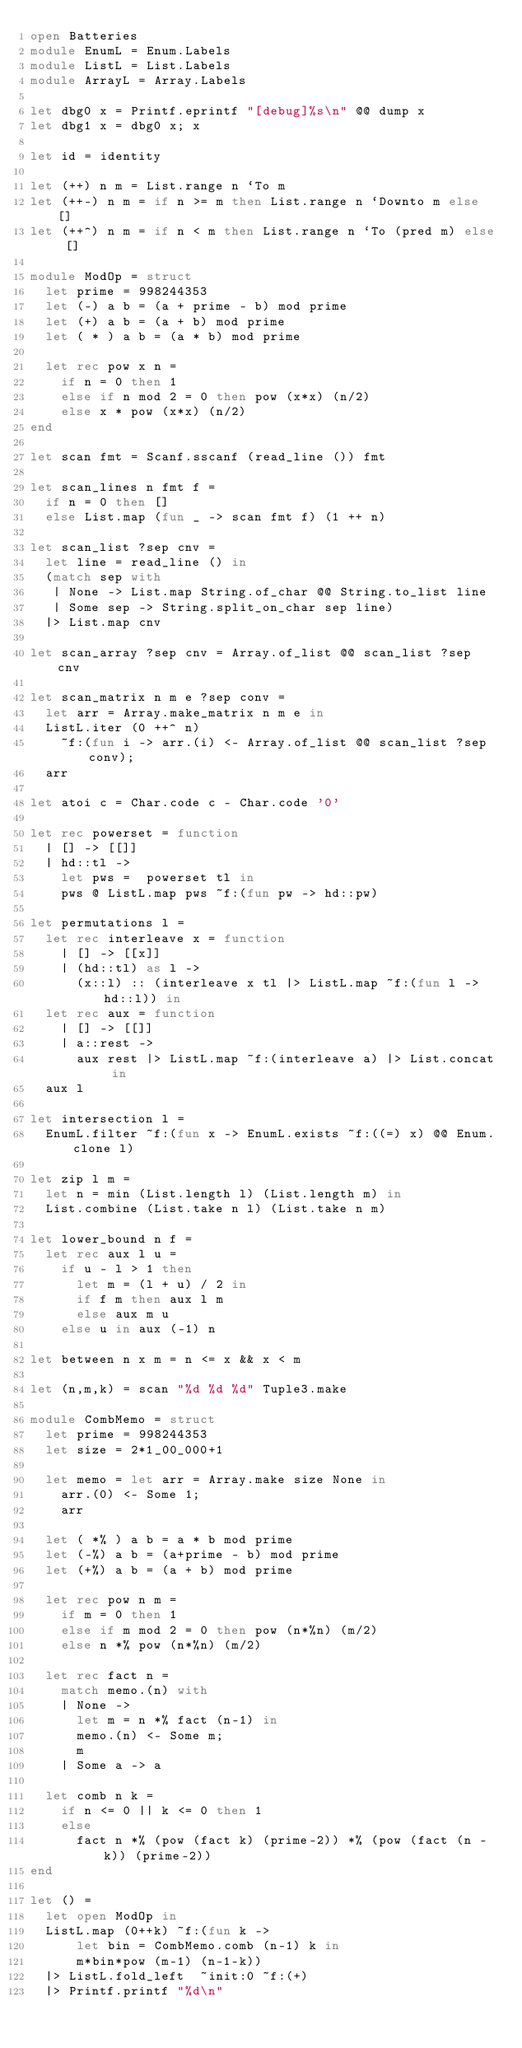Convert code to text. <code><loc_0><loc_0><loc_500><loc_500><_OCaml_>open Batteries
module EnumL = Enum.Labels
module ListL = List.Labels
module ArrayL = Array.Labels

let dbg0 x = Printf.eprintf "[debug]%s\n" @@ dump x
let dbg1 x = dbg0 x; x

let id = identity

let (++) n m = List.range n `To m
let (++-) n m = if n >= m then List.range n `Downto m else []
let (++^) n m = if n < m then List.range n `To (pred m) else []

module ModOp = struct
  let prime = 998244353
  let (-) a b = (a + prime - b) mod prime
  let (+) a b = (a + b) mod prime
  let ( * ) a b = (a * b) mod prime

  let rec pow x n =
    if n = 0 then 1
    else if n mod 2 = 0 then pow (x*x) (n/2)
    else x * pow (x*x) (n/2)
end

let scan fmt = Scanf.sscanf (read_line ()) fmt

let scan_lines n fmt f =
  if n = 0 then []
  else List.map (fun _ -> scan fmt f) (1 ++ n)

let scan_list ?sep cnv =
  let line = read_line () in
  (match sep with
   | None -> List.map String.of_char @@ String.to_list line
   | Some sep -> String.split_on_char sep line)
  |> List.map cnv

let scan_array ?sep cnv = Array.of_list @@ scan_list ?sep cnv

let scan_matrix n m e ?sep conv =
  let arr = Array.make_matrix n m e in
  ListL.iter (0 ++^ n)
    ~f:(fun i -> arr.(i) <- Array.of_list @@ scan_list ?sep conv);
  arr

let atoi c = Char.code c - Char.code '0'

let rec powerset = function
  | [] -> [[]]
  | hd::tl ->
    let pws =  powerset tl in
    pws @ ListL.map pws ~f:(fun pw -> hd::pw)

let permutations l =
  let rec interleave x = function
    | [] -> [[x]]
    | (hd::tl) as l ->
      (x::l) :: (interleave x tl |> ListL.map ~f:(fun l -> hd::l)) in
  let rec aux = function
    | [] -> [[]]
    | a::rest ->
      aux rest |> ListL.map ~f:(interleave a) |> List.concat in
  aux l

let intersection l =
  EnumL.filter ~f:(fun x -> EnumL.exists ~f:((=) x) @@ Enum.clone l)

let zip l m =
  let n = min (List.length l) (List.length m) in
  List.combine (List.take n l) (List.take n m)

let lower_bound n f =
  let rec aux l u =
    if u - l > 1 then
      let m = (l + u) / 2 in
      if f m then aux l m
      else aux m u
    else u in aux (-1) n

let between n x m = n <= x && x < m

let (n,m,k) = scan "%d %d %d" Tuple3.make

module CombMemo = struct
  let prime = 998244353
  let size = 2*1_00_000+1

  let memo = let arr = Array.make size None in
    arr.(0) <- Some 1;
    arr

  let ( *% ) a b = a * b mod prime
  let (-%) a b = (a+prime - b) mod prime
  let (+%) a b = (a + b) mod prime

  let rec pow n m =
    if m = 0 then 1
    else if m mod 2 = 0 then pow (n*%n) (m/2)
    else n *% pow (n*%n) (m/2)

  let rec fact n =
    match memo.(n) with
    | None ->
      let m = n *% fact (n-1) in
      memo.(n) <- Some m;
      m
    | Some a -> a

  let comb n k =
    if n <= 0 || k <= 0 then 1
    else
      fact n *% (pow (fact k) (prime-2)) *% (pow (fact (n - k)) (prime-2))
end

let () =
  let open ModOp in
  ListL.map (0++k) ~f:(fun k ->
      let bin = CombMemo.comb (n-1) k in
      m*bin*pow (m-1) (n-1-k))
  |> ListL.fold_left  ~init:0 ~f:(+)
  |> Printf.printf "%d\n"
</code> 